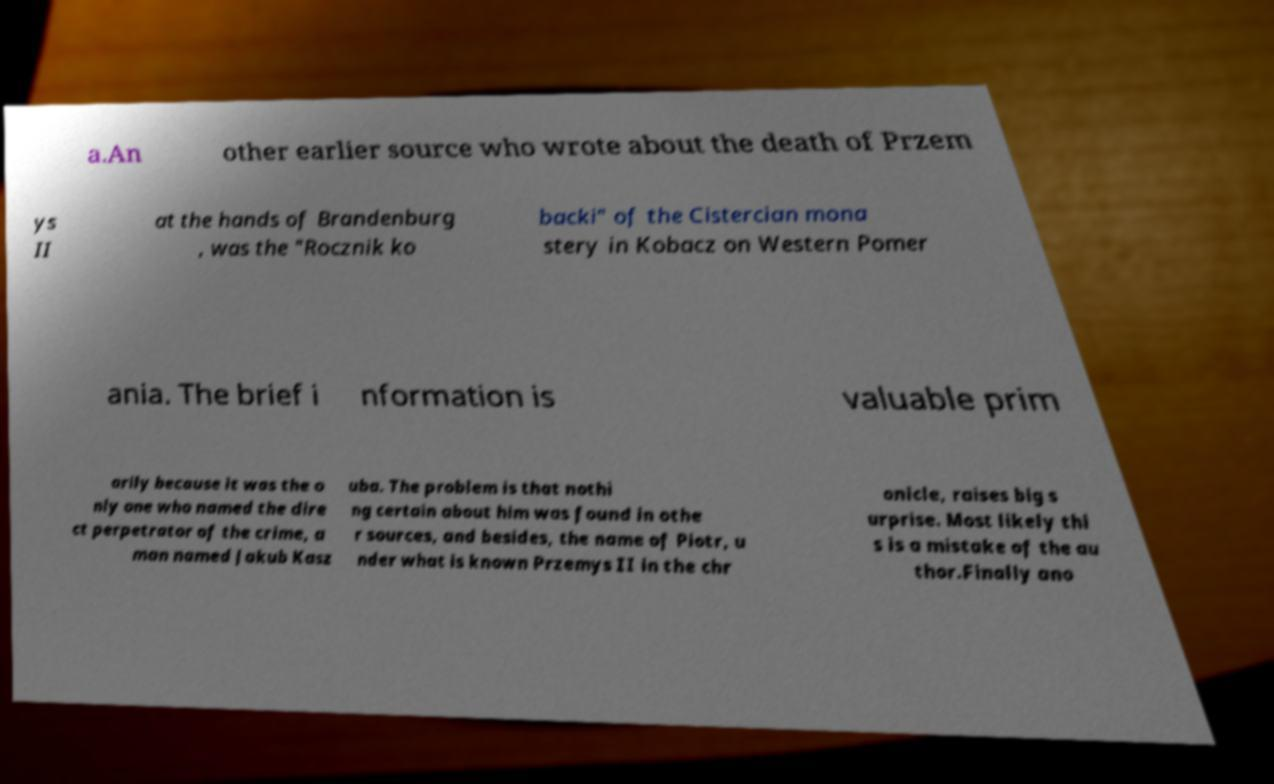For documentation purposes, I need the text within this image transcribed. Could you provide that? a.An other earlier source who wrote about the death of Przem ys II at the hands of Brandenburg , was the "Rocznik ko backi" of the Cistercian mona stery in Kobacz on Western Pomer ania. The brief i nformation is valuable prim arily because it was the o nly one who named the dire ct perpetrator of the crime, a man named Jakub Kasz uba. The problem is that nothi ng certain about him was found in othe r sources, and besides, the name of Piotr, u nder what is known Przemys II in the chr onicle, raises big s urprise. Most likely thi s is a mistake of the au thor.Finally ano 